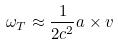Convert formula to latex. <formula><loc_0><loc_0><loc_500><loc_500>\omega _ { T } \approx \frac { 1 } { 2 c ^ { 2 } } a \times v</formula> 